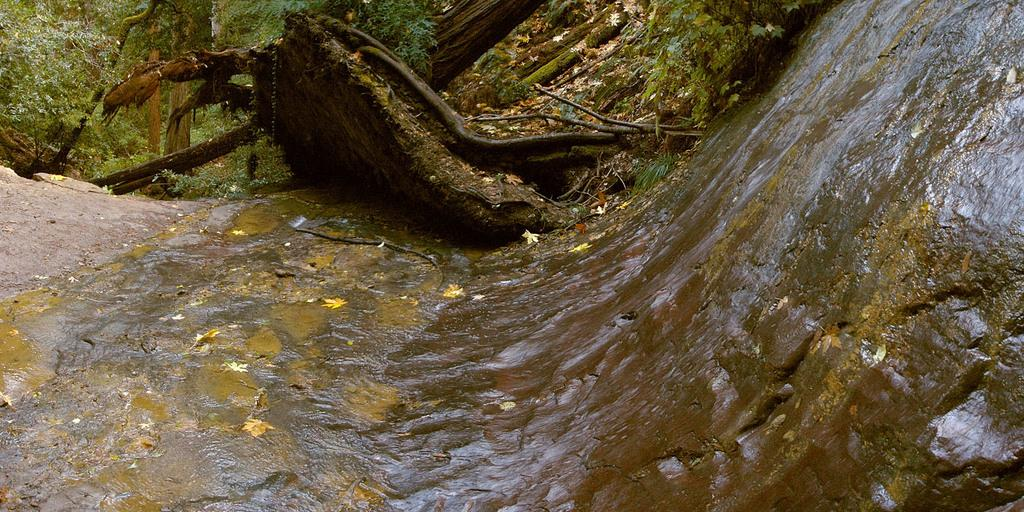What type of vegetation can be seen in the image? There are trees in the image. What else can be found on the ground in the image? Wood logs and dry leaves are visible in the image. What other natural elements are present in the image? Rocks are in the image. Is there any water visible in the image? Yes, there is water in the image. What is the surface on which the trees, wood logs, dry leaves, rocks, and water are located? The ground is visible in the image. What type of channel can be seen in the image? There is no channel present in the image. Is there a bear visible in the image? No, there is no bear present in the image. 